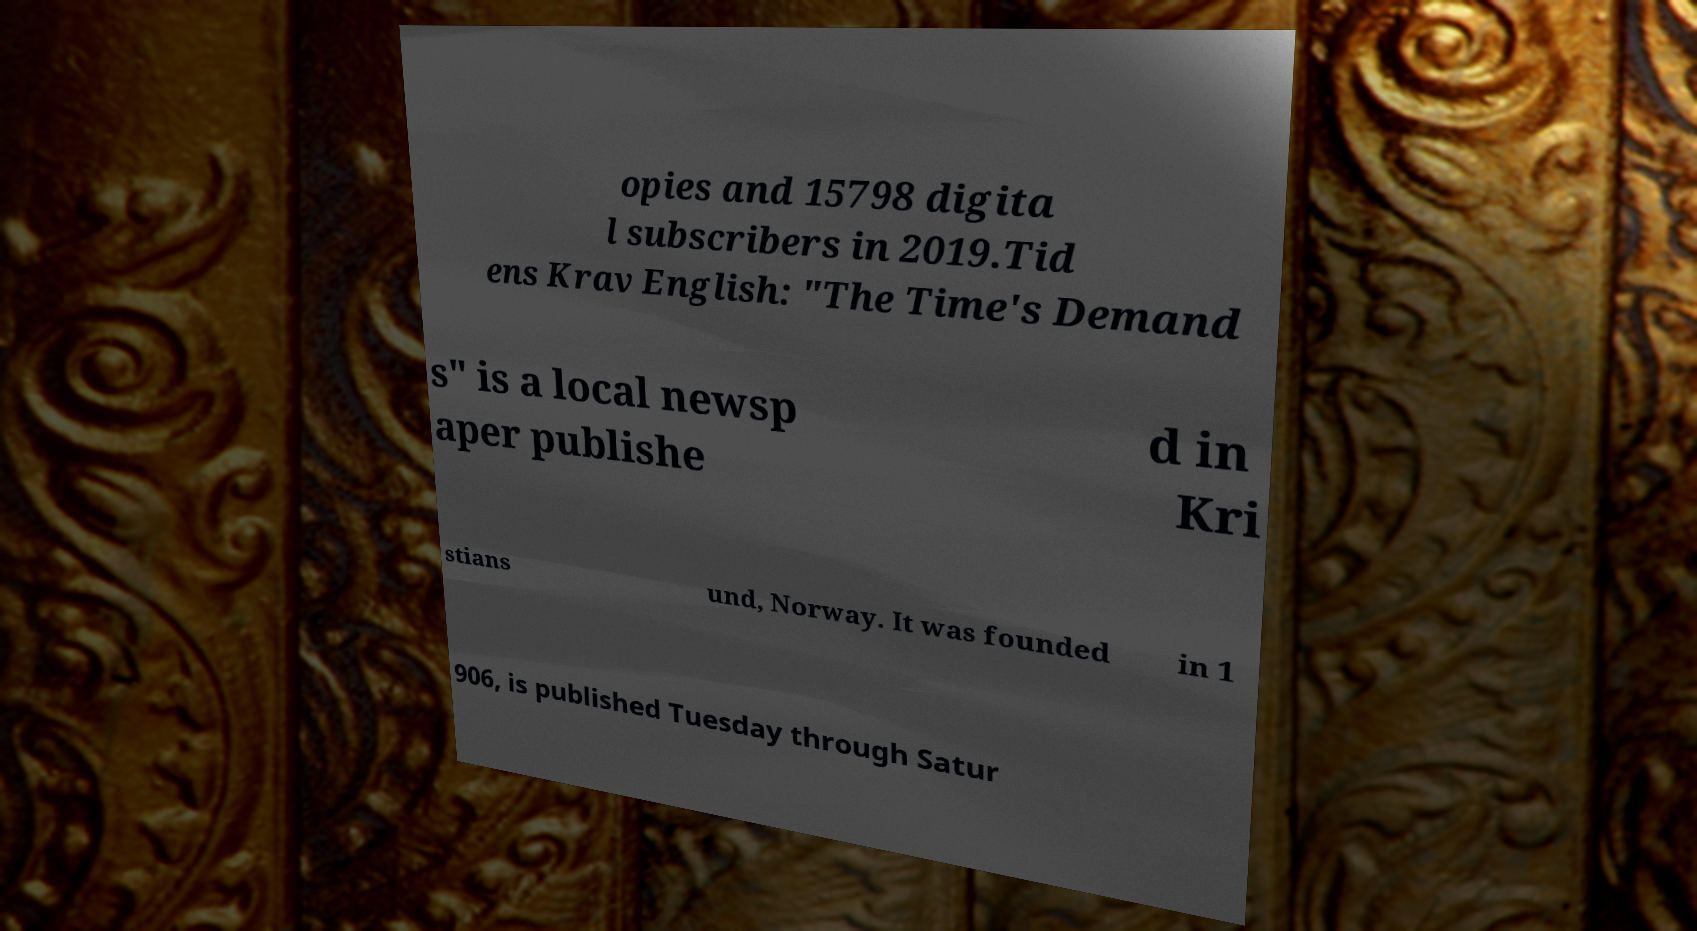Could you extract and type out the text from this image? opies and 15798 digita l subscribers in 2019.Tid ens Krav English: "The Time's Demand s" is a local newsp aper publishe d in Kri stians und, Norway. It was founded in 1 906, is published Tuesday through Satur 